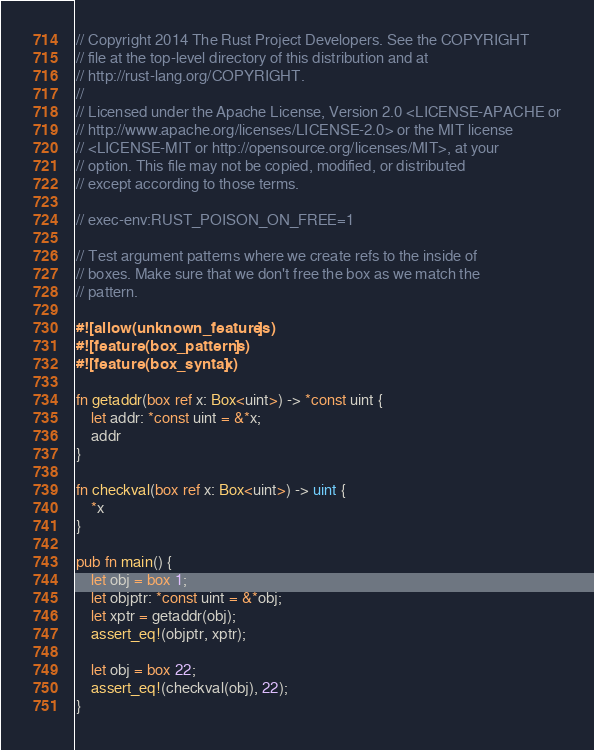Convert code to text. <code><loc_0><loc_0><loc_500><loc_500><_Rust_>// Copyright 2014 The Rust Project Developers. See the COPYRIGHT
// file at the top-level directory of this distribution and at
// http://rust-lang.org/COPYRIGHT.
//
// Licensed under the Apache License, Version 2.0 <LICENSE-APACHE or
// http://www.apache.org/licenses/LICENSE-2.0> or the MIT license
// <LICENSE-MIT or http://opensource.org/licenses/MIT>, at your
// option. This file may not be copied, modified, or distributed
// except according to those terms.

// exec-env:RUST_POISON_ON_FREE=1

// Test argument patterns where we create refs to the inside of
// boxes. Make sure that we don't free the box as we match the
// pattern.

#![allow(unknown_features)]
#![feature(box_patterns)]
#![feature(box_syntax)]

fn getaddr(box ref x: Box<uint>) -> *const uint {
    let addr: *const uint = &*x;
    addr
}

fn checkval(box ref x: Box<uint>) -> uint {
    *x
}

pub fn main() {
    let obj = box 1;
    let objptr: *const uint = &*obj;
    let xptr = getaddr(obj);
    assert_eq!(objptr, xptr);

    let obj = box 22;
    assert_eq!(checkval(obj), 22);
}
</code> 